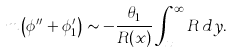Convert formula to latex. <formula><loc_0><loc_0><loc_500><loc_500>m \left ( \phi ^ { \prime \prime } + \phi ^ { \prime } _ { 1 } \right ) \sim - \frac { \theta _ { 1 } } { R ( x ) } \int _ { x } ^ { \infty } R \, d y .</formula> 